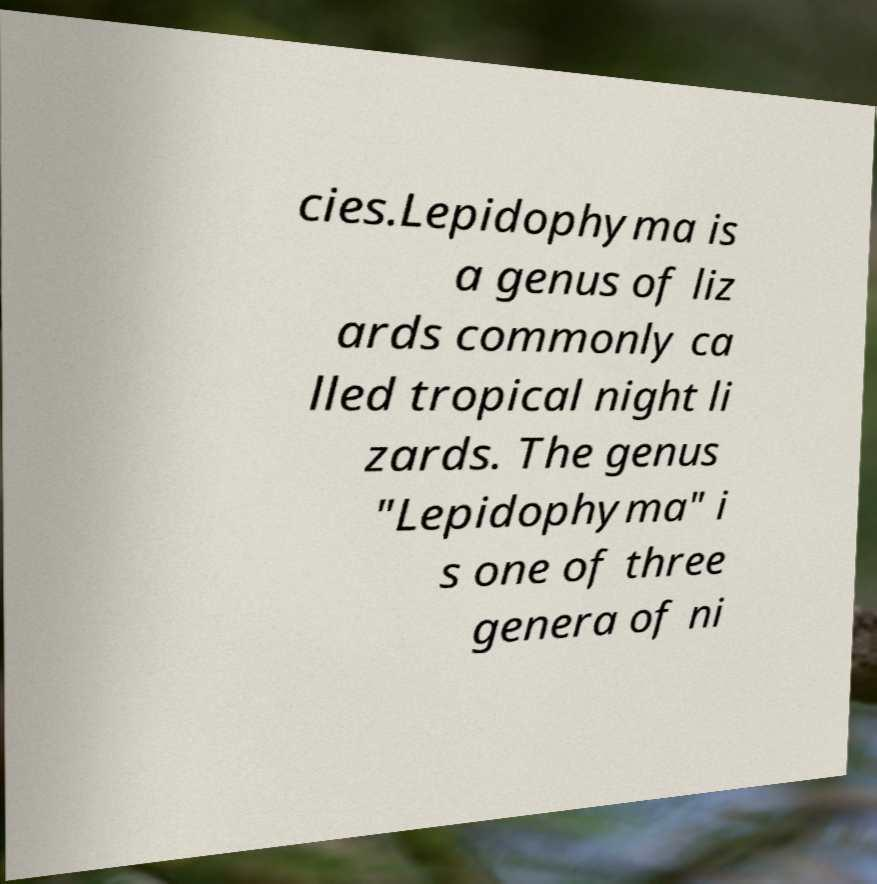Could you extract and type out the text from this image? cies.Lepidophyma is a genus of liz ards commonly ca lled tropical night li zards. The genus "Lepidophyma" i s one of three genera of ni 